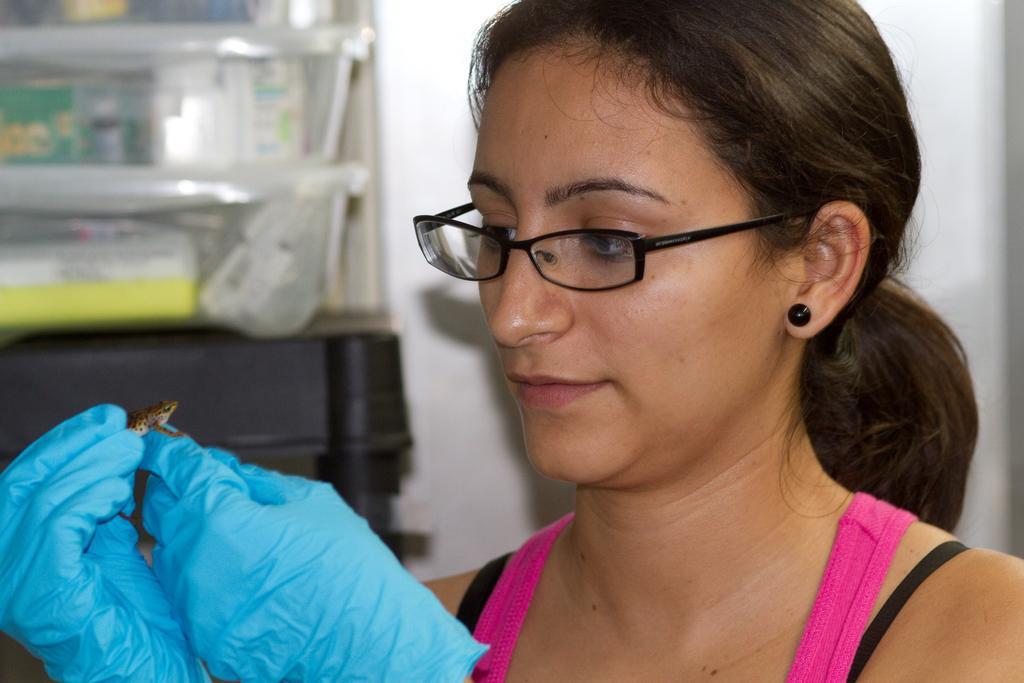Could you give a brief overview of what you see in this image? In this image, we can see a person wearing gloves and holding a frog with her hand. There are boxes on the left side of the image. 